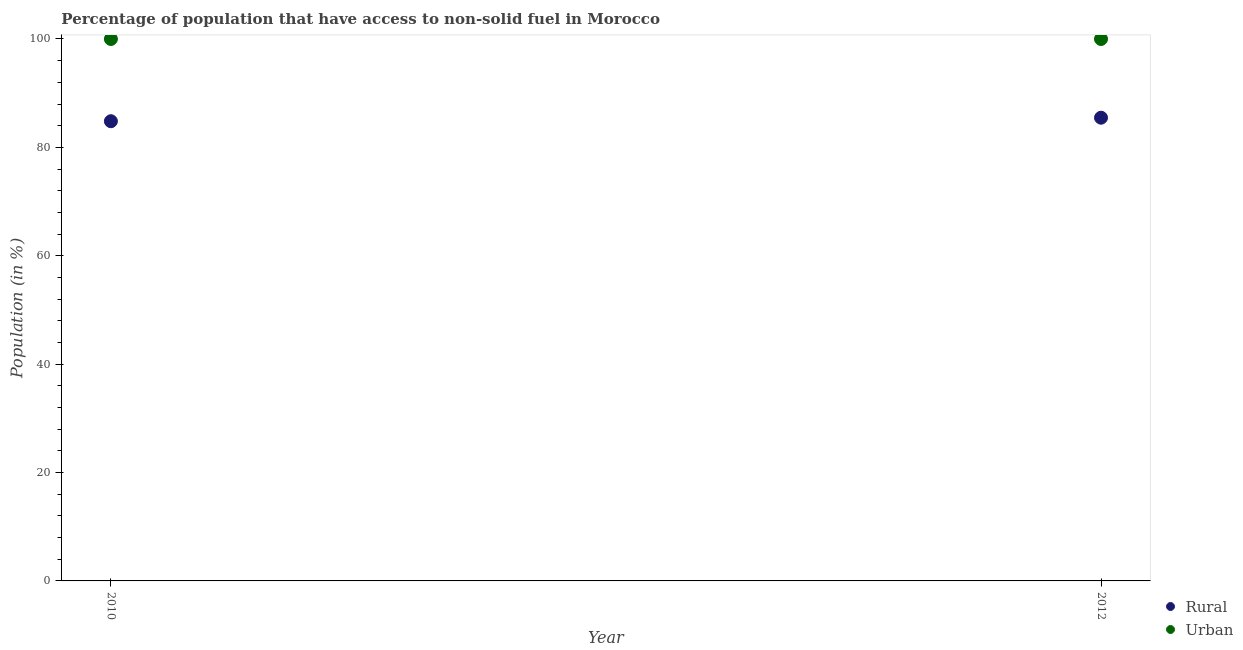How many different coloured dotlines are there?
Keep it short and to the point. 2. What is the urban population in 2010?
Your answer should be compact. 100. Across all years, what is the maximum urban population?
Offer a terse response. 100. Across all years, what is the minimum urban population?
Give a very brief answer. 100. In which year was the urban population maximum?
Provide a succinct answer. 2010. In which year was the rural population minimum?
Provide a succinct answer. 2010. What is the total rural population in the graph?
Your answer should be very brief. 170.3. What is the difference between the urban population in 2010 and that in 2012?
Provide a short and direct response. 0. What is the difference between the urban population in 2010 and the rural population in 2012?
Your answer should be very brief. 14.52. In the year 2010, what is the difference between the rural population and urban population?
Make the answer very short. -15.18. In how many years, is the urban population greater than 24 %?
Provide a short and direct response. 2. What is the ratio of the rural population in 2010 to that in 2012?
Provide a short and direct response. 0.99. Is the urban population in 2010 less than that in 2012?
Give a very brief answer. No. Is the urban population strictly greater than the rural population over the years?
Make the answer very short. Yes. Is the urban population strictly less than the rural population over the years?
Ensure brevity in your answer.  No. How many dotlines are there?
Offer a very short reply. 2. Are the values on the major ticks of Y-axis written in scientific E-notation?
Your answer should be very brief. No. What is the title of the graph?
Your answer should be compact. Percentage of population that have access to non-solid fuel in Morocco. What is the Population (in %) in Rural in 2010?
Your answer should be very brief. 84.82. What is the Population (in %) of Urban in 2010?
Your response must be concise. 100. What is the Population (in %) in Rural in 2012?
Keep it short and to the point. 85.48. What is the Population (in %) of Urban in 2012?
Offer a terse response. 100. Across all years, what is the maximum Population (in %) in Rural?
Ensure brevity in your answer.  85.48. Across all years, what is the minimum Population (in %) in Rural?
Your response must be concise. 84.82. Across all years, what is the minimum Population (in %) in Urban?
Offer a terse response. 100. What is the total Population (in %) of Rural in the graph?
Make the answer very short. 170.3. What is the total Population (in %) in Urban in the graph?
Offer a very short reply. 200. What is the difference between the Population (in %) of Rural in 2010 and that in 2012?
Offer a terse response. -0.65. What is the difference between the Population (in %) of Rural in 2010 and the Population (in %) of Urban in 2012?
Keep it short and to the point. -15.18. What is the average Population (in %) in Rural per year?
Ensure brevity in your answer.  85.15. In the year 2010, what is the difference between the Population (in %) in Rural and Population (in %) in Urban?
Provide a short and direct response. -15.18. In the year 2012, what is the difference between the Population (in %) in Rural and Population (in %) in Urban?
Your answer should be compact. -14.52. What is the ratio of the Population (in %) of Rural in 2010 to that in 2012?
Your answer should be compact. 0.99. What is the difference between the highest and the second highest Population (in %) of Rural?
Keep it short and to the point. 0.65. What is the difference between the highest and the lowest Population (in %) in Rural?
Your answer should be very brief. 0.65. What is the difference between the highest and the lowest Population (in %) of Urban?
Keep it short and to the point. 0. 